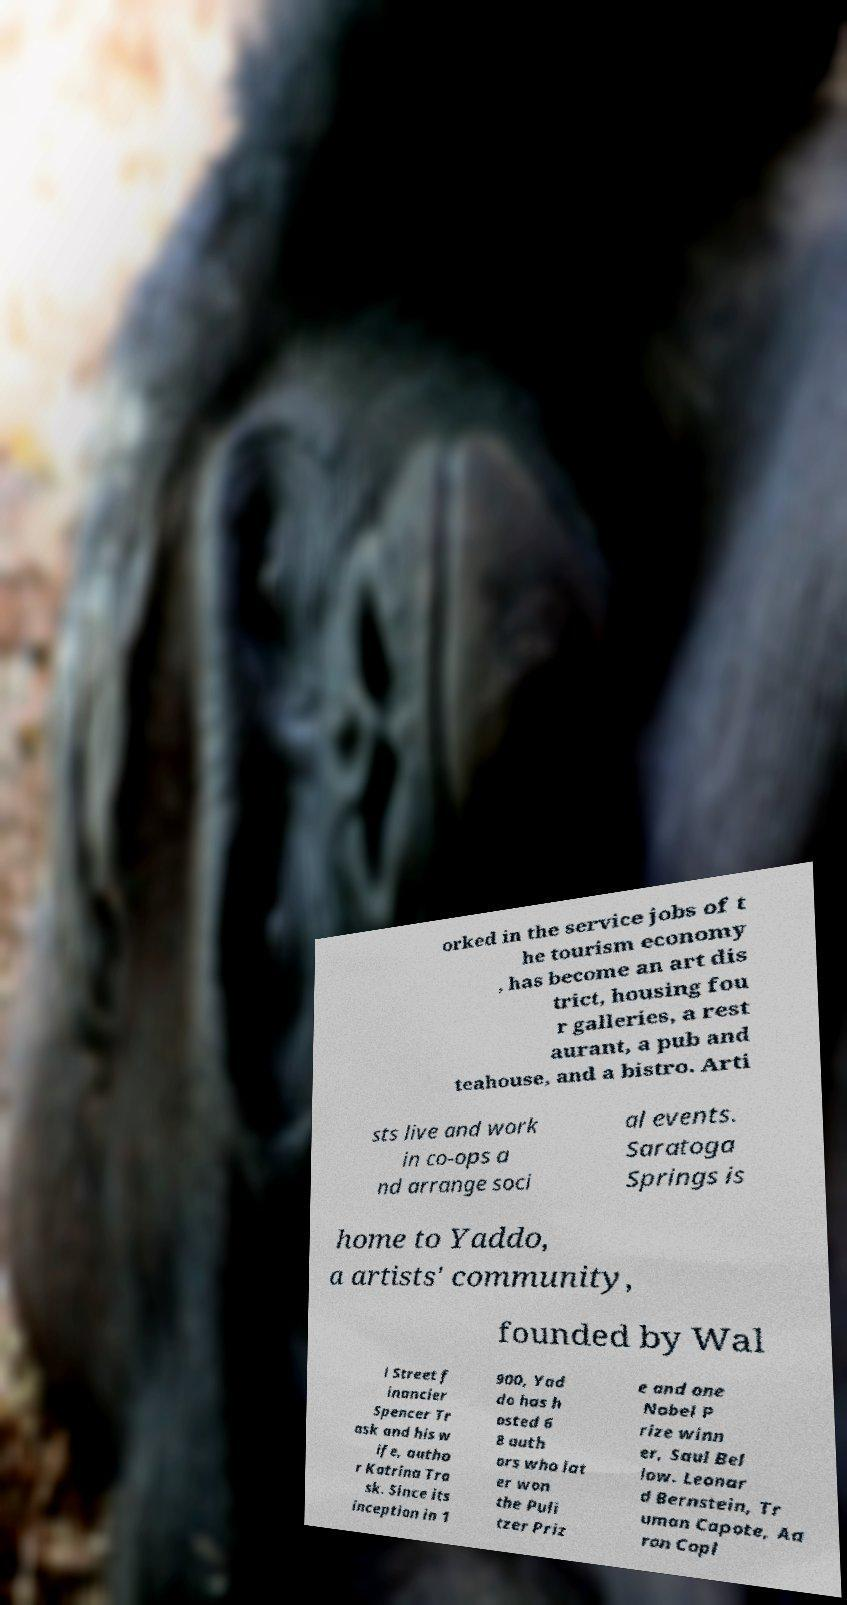What messages or text are displayed in this image? I need them in a readable, typed format. orked in the service jobs of t he tourism economy , has become an art dis trict, housing fou r galleries, a rest aurant, a pub and teahouse, and a bistro. Arti sts live and work in co-ops a nd arrange soci al events. Saratoga Springs is home to Yaddo, a artists' community, founded by Wal l Street f inancier Spencer Tr ask and his w ife, autho r Katrina Tra sk. Since its inception in 1 900, Yad do has h osted 6 8 auth ors who lat er won the Puli tzer Priz e and one Nobel P rize winn er, Saul Bel low. Leonar d Bernstein, Tr uman Capote, Aa ron Copl 